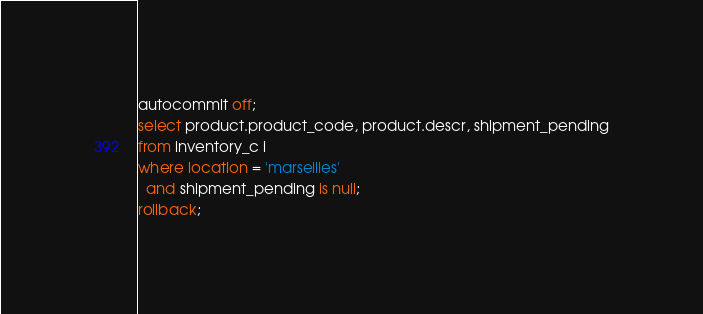Convert code to text. <code><loc_0><loc_0><loc_500><loc_500><_SQL_>autocommit off;
select product.product_code, product.descr, shipment_pending
from inventory_c i
where location = 'marseilles'
  and shipment_pending is null;
rollback;
</code> 